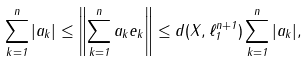<formula> <loc_0><loc_0><loc_500><loc_500>\sum _ { k = 1 } ^ { n } | a _ { k } | \leq \left \| \sum _ { k = 1 } ^ { n } a _ { k } e _ { k } \right \| \leq d ( X , \ell _ { 1 } ^ { n + 1 } ) \sum _ { k = 1 } ^ { n } | a _ { k } | ,</formula> 